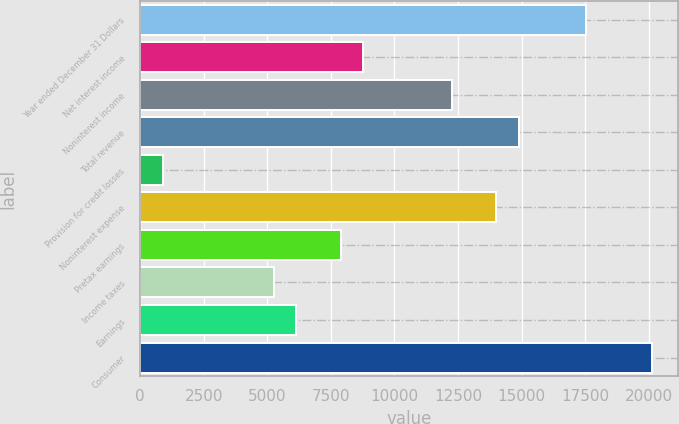Convert chart. <chart><loc_0><loc_0><loc_500><loc_500><bar_chart><fcel>Year ended December 31 Dollars<fcel>Net interest income<fcel>Noninterest income<fcel>Total revenue<fcel>Provision for credit losses<fcel>Noninterest expense<fcel>Pretax earnings<fcel>Income taxes<fcel>Earnings<fcel>Consumer<nl><fcel>17515.8<fcel>8759.03<fcel>12261.8<fcel>14888.8<fcel>877.84<fcel>14013.1<fcel>7883.35<fcel>5256.28<fcel>6131.97<fcel>20142.9<nl></chart> 